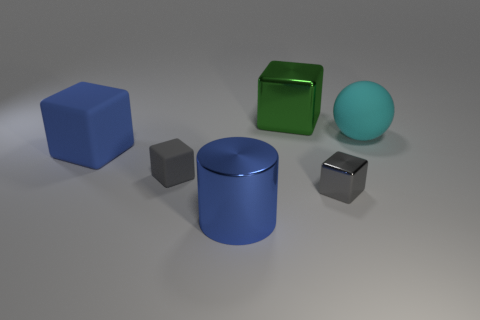Is the material of the big green cube the same as the large blue block?
Offer a terse response. No. How many spheres are cyan rubber things or large objects?
Offer a very short reply. 1. What size is the matte object in front of the big block that is in front of the cyan object behind the small gray shiny cube?
Make the answer very short. Small. What size is the gray metal thing that is the same shape as the tiny matte thing?
Ensure brevity in your answer.  Small. How many small rubber things are to the left of the big cyan matte sphere?
Give a very brief answer. 1. Does the block that is behind the large cyan thing have the same color as the big sphere?
Make the answer very short. No. What number of gray objects are either small metallic cylinders or big spheres?
Provide a short and direct response. 0. What is the color of the big cube that is on the right side of the gray rubber cube in front of the cyan object?
Offer a terse response. Green. What material is the other block that is the same color as the tiny matte block?
Ensure brevity in your answer.  Metal. What is the color of the rubber thing that is in front of the large blue block?
Provide a succinct answer. Gray. 